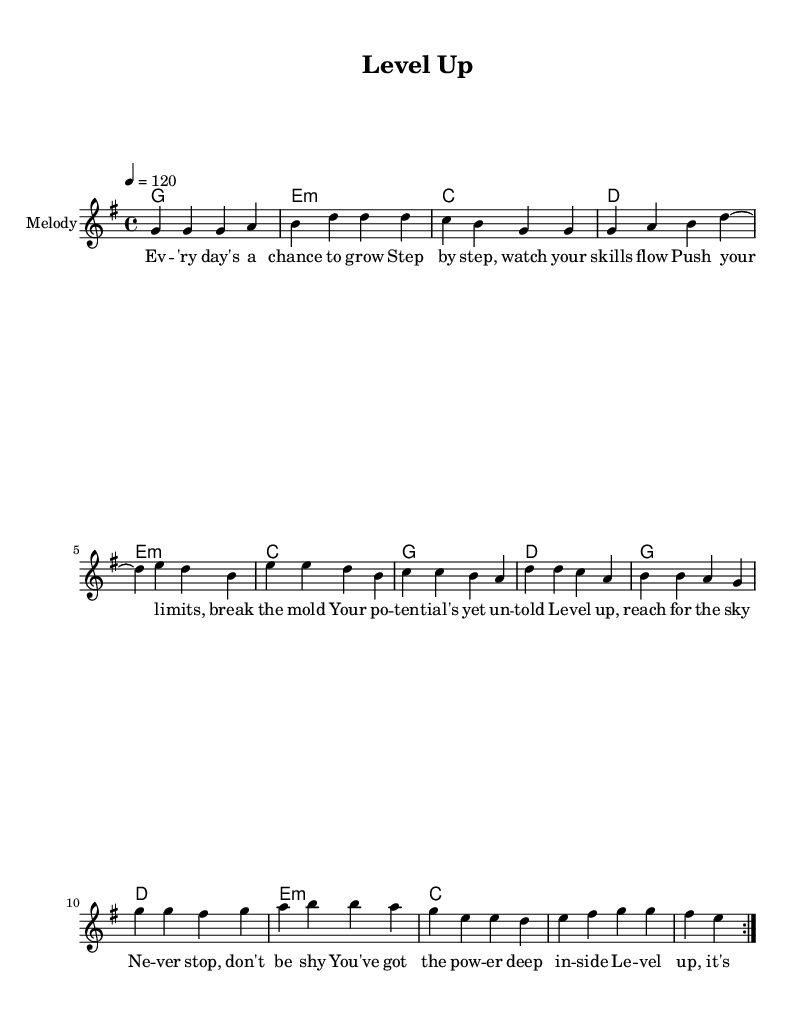What is the key signature of this music? The key signature is G major, which has one sharp (F sharp). This can be identified by the symbol that appears after the clef at the beginning of the score.
Answer: G major What is the time signature of this music? The time signature is 4/4, which is indicated by the two numbers shown at the beginning of the piece. The top number (4) represents the number of beats in a measure, while the bottom number (4) indicates that a quarter note gets one beat.
Answer: 4/4 What is the tempo of the music? The tempo is 120 beats per minute, as shown in the text that indicates the speed of the piece (4 = 120). This means that there are 120 quarter-note beats in one minute.
Answer: 120 How many measures are in the melody section? The melody section has 8 measures, which can be verified by counting the individual groupings of beats separated by bar lines from the first to the last note in the melody.
Answer: 8 What chords are used in the first line of the harmonies? The first line of the harmonies consists of G, E minor, C, and D chords, as indicated by the chord names written above the measures corresponding to the melody notes.
Answer: G, E minor, C, D What is the main theme of the lyrics? The main theme of the lyrics is personal growth and empowerment, speaking about taking steps to improve skills and not being afraid to shine. This can be inferred from the content of the lyrics that emphasize growing, reaching potential, and having inner power.
Answer: Personal growth How many times is the main melody repeated? The main melody is repeated two times, as indicated by the "repeat volta 2" instruction at the beginning of the melody section. This signifies that the section should be played twice before moving on.
Answer: 2 